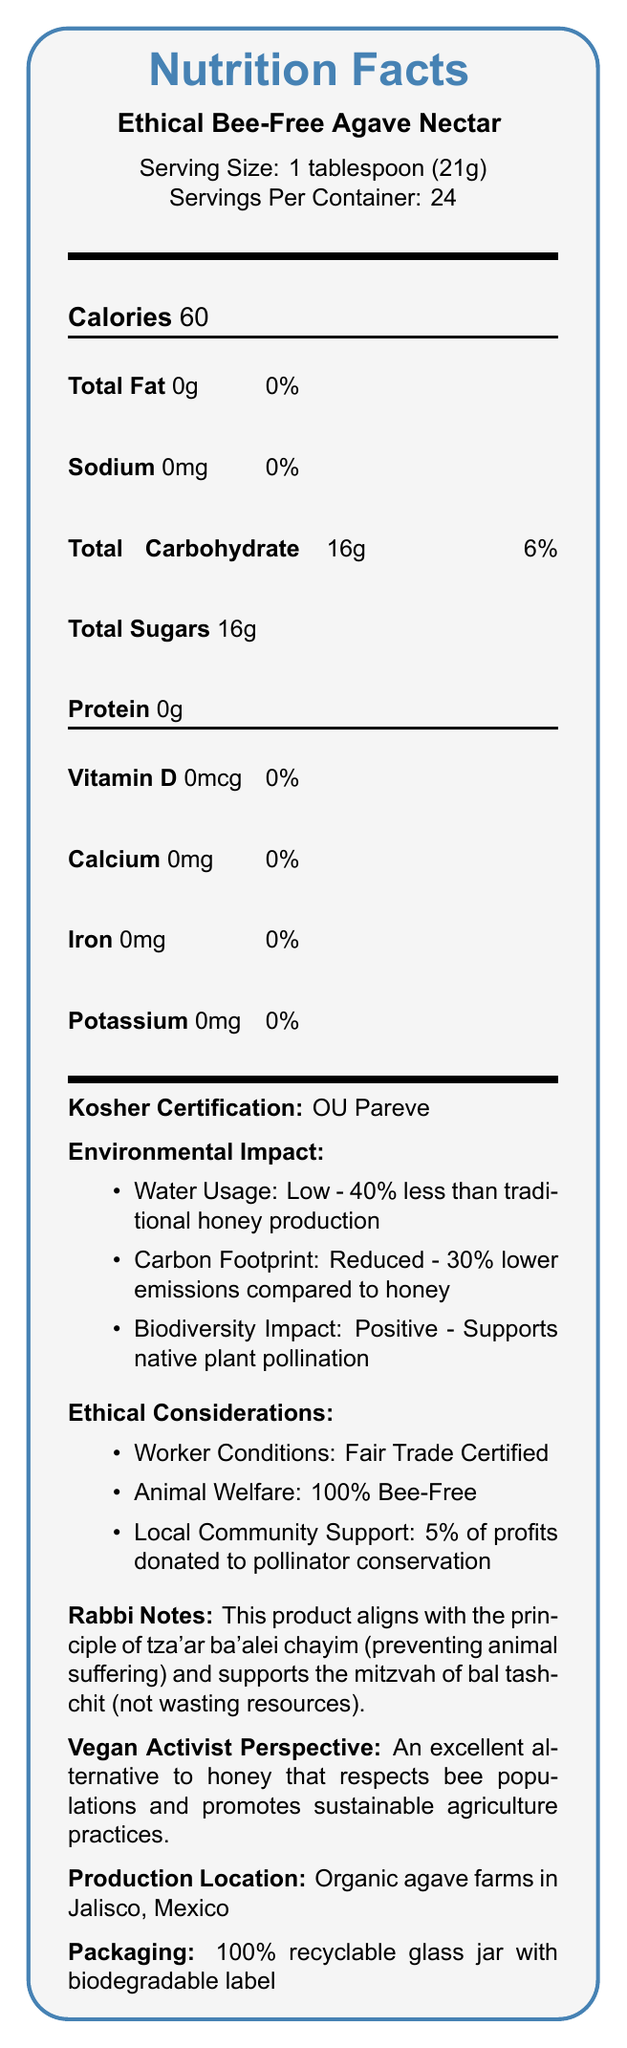what is the serving size for Ethical Bee-Free Agave Nectar? The serving size is mentioned at the top of the document near the product name.
Answer: 1 tablespoon (21g) how many servings are in one container? The document states that there are 24 servings per container, listed right below the serving size.
Answer: 24 how many calories are in one serving of Ethical Bee-Free Agave Nectar? The number of calories per serving is indicated immediately after the servings per container, in bold text.
Answer: 60 does the product contain any fat? The document lists "Total Fat" as 0g with 0% Daily Value, which indicates that the product does not contain any fat.
Answer: No what vitamins and minerals does the product contain? The entries under Vitamin D, calcium, iron, and potassium all list 0mcg or 0mg with a 0% daily value, indicating the absence of these nutrients.
Answer: It contains no Vitamin D, calcium, iron, or potassium. which kosher certification does the product have? The document notes "Kosher Certification: OU Pareve" in a separate section.
Answer: OU Pareve what is the water usage impact compared to traditional honey production? The environment impact section states that the water usage is low and 40% less than traditional honey production.
Answer: 40% less how does this product support biodiversity? The document specifically mentions that the biodiversity impact is positive and supports native plant pollination.
Answer: Supports native plant pollination describe the ethical considerations associated with the product. The ethical considerations section lists worker conditions as "Fair Trade Certified", animal welfare as "100% Bee-Free", and states that 5% of profits are donated to pollinator conservation.
Answer: Fair Trade Certified, 100% Bee-Free, 5% of profits donated to pollinator conservation how is the packaging of the product environmentally friendly? The document mentions that the packaging is a 100% recyclable glass jar with a biodegradable label.
Answer: 100% recyclable glass jar with a biodegradable label what does the rabbi notes section mention about the product in relation to Jewish principles? The document specifically states that the product aligns with these Jewish principles.
Answer: It aligns with tza'ar ba'alei chayim (preventing animal suffering) and supports bal tashchit (not wasting resources). who benefits from the 5% profit donation? According to the ethical considerations section, 5% of profits are donated to pollinator conservation.
Answer: Pollinator conservation efforts which statements about the environmental impact of the product are true? I. Reduced water usage II. Higher carbon footprint III. Positive impact on biodiversity The document lists reduced water usage (40% less) and positive impact on biodiversity (supports native plant pollination). The carbon footprint is reduced, thereby statement II is incorrect.
Answer: I and III how many grams of total sugars are in one serving? Under total carbohydrate, the document specifically lists total sugars as 16g.
Answer: 16g is the product manufactured in the USA? The production location is listed as "Organic agave farms in Jalisco, Mexico".
Answer: No summary The summary captures the essential information from various sections of the document, providing a comprehensive overview.
Answer: The document is the Nutrition Facts Label for Ethical Bee-Free Agave Nectar. It provides detailed nutritional information, ethical and environmental considerations, kosher certification, rabbi notes, and packaging details. The product is bee-free, Fair Trade Certified, and supports pollinator conservation, demonstrating reduced environmental impact and aligning with Jewish principles of preventing animal suffering and avoiding resource waste. which nutrient is not present at all in the product? A. Calcium B. Iron C. Potassium D. All of the above The document shows 0% Daily Value for Calcium, Iron, and Potassium, indicating they are not present in the product.
Answer: D. All of the above what percentage of the packaging is recyclable? The packaging section states the jar is made of 100% recyclable glass.
Answer: 100% how does the product compare to honey in terms of carbon emissions? The environmental impact section notes that the product has a 30% lower carbon footprint compared to honey.
Answer: Reduced - 30% lower emissions compared to honey does the product support the vegan community according to the vegan activist perspective? The vegan activist perspective states that the product is an excellent alternative to honey that respects bee populations and promotes sustainable agriculture practices.
Answer: Yes how much protein does Ethical Bee-Free Agave Nectar contain? The document lists protein content as 0g.
Answer: 0g can you determine the exact worker conditions from the document? The document specifies "Fair Trade Certified" under worker conditions, which implies fair working conditions, but does not provide exact details of working conditions.
Answer: Fair Trade Certified what is the main difference in water usage between this product and traditional honey production? A. 10% less B. 20% less C. 30% less D. 40% less The document states that Ethical Bee-Free Agave Nectar uses 40% less water compared to traditional honey production.
Answer: D. 40% less 